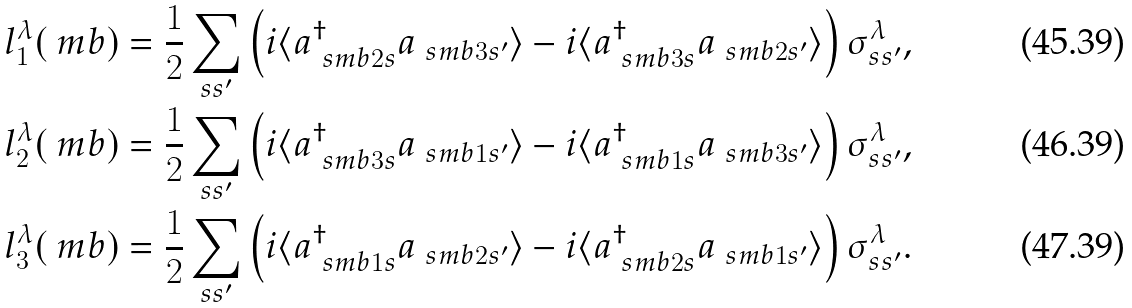Convert formula to latex. <formula><loc_0><loc_0><loc_500><loc_500>l _ { 1 } ^ { \lambda } ( \ m b ) & = \frac { 1 } { 2 } \sum _ { s s ^ { \prime } } \left ( i \langle a ^ { \dag } _ { \ s m b 2 s } a _ { \ s m b 3 s ^ { \prime } } \rangle - i \langle a ^ { \dag } _ { \ s m b 3 s } a _ { \ s m b 2 s ^ { \prime } } \rangle \right ) \sigma ^ { \lambda } _ { s s ^ { \prime } } , \\ l _ { 2 } ^ { \lambda } ( \ m b ) & = \frac { 1 } { 2 } \sum _ { s s ^ { \prime } } \left ( i \langle a ^ { \dag } _ { \ s m b 3 s } a _ { \ s m b 1 s ^ { \prime } } \rangle - i \langle a ^ { \dag } _ { \ s m b 1 s } a _ { \ s m b 3 s ^ { \prime } } \rangle \right ) \sigma ^ { \lambda } _ { s s ^ { \prime } } , \\ l _ { 3 } ^ { \lambda } ( \ m b ) & = \frac { 1 } { 2 } \sum _ { s s ^ { \prime } } \left ( i \langle a ^ { \dag } _ { \ s m b 1 s } a _ { \ s m b 2 s ^ { \prime } } \rangle - i \langle a ^ { \dag } _ { \ s m b 2 s } a _ { \ s m b 1 s ^ { \prime } } \rangle \right ) \sigma ^ { \lambda } _ { s s ^ { \prime } } .</formula> 